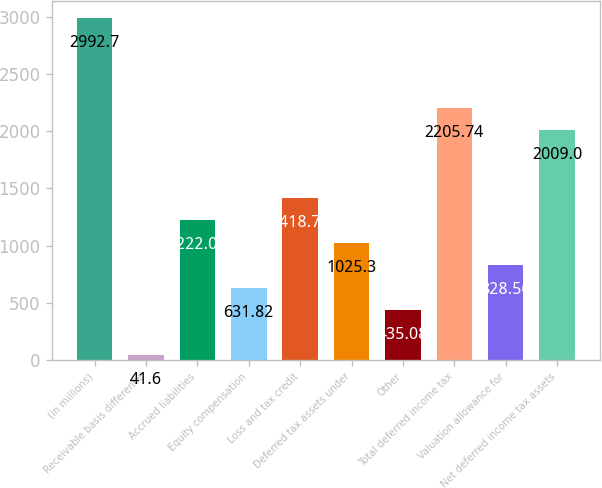<chart> <loc_0><loc_0><loc_500><loc_500><bar_chart><fcel>(in millions)<fcel>Receivable basis difference<fcel>Accrued liabilities<fcel>Equity compensation<fcel>Loss and tax credit<fcel>Deferred tax assets under<fcel>Other<fcel>Total deferred income tax<fcel>Valuation allowance for<fcel>Net deferred income tax assets<nl><fcel>2992.7<fcel>41.6<fcel>1222.04<fcel>631.82<fcel>1418.78<fcel>1025.3<fcel>435.08<fcel>2205.74<fcel>828.56<fcel>2009<nl></chart> 